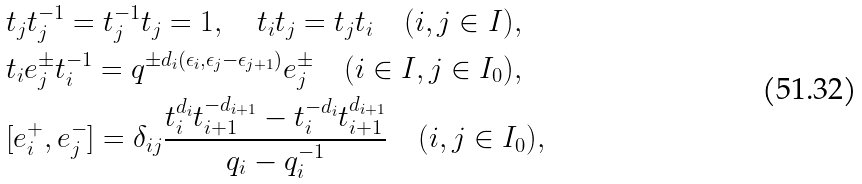<formula> <loc_0><loc_0><loc_500><loc_500>& t _ { j } t _ { j } ^ { - 1 } = t _ { j } ^ { - 1 } t _ { j } = 1 , \quad t _ { i } t _ { j } = t _ { j } t _ { i } \quad ( i , j \in I ) , \\ & t _ { i } e _ { j } ^ { \pm } t _ { i } ^ { - 1 } = q ^ { \pm d _ { i } ( \epsilon _ { i } , \epsilon _ { j } - \epsilon _ { j + 1 } ) } e _ { j } ^ { \pm } \quad ( i \in I , j \in I _ { 0 } ) , \\ & [ e _ { i } ^ { + } , e _ { j } ^ { - } ] = \delta _ { i j } \frac { t _ { i } ^ { d _ { i } } t _ { i + 1 } ^ { - d _ { i + 1 } } - t _ { i } ^ { - d _ { i } } t _ { i + 1 } ^ { d _ { i + 1 } } } { q _ { i } - q _ { i } ^ { - 1 } } \quad ( i , j \in I _ { 0 } ) ,</formula> 